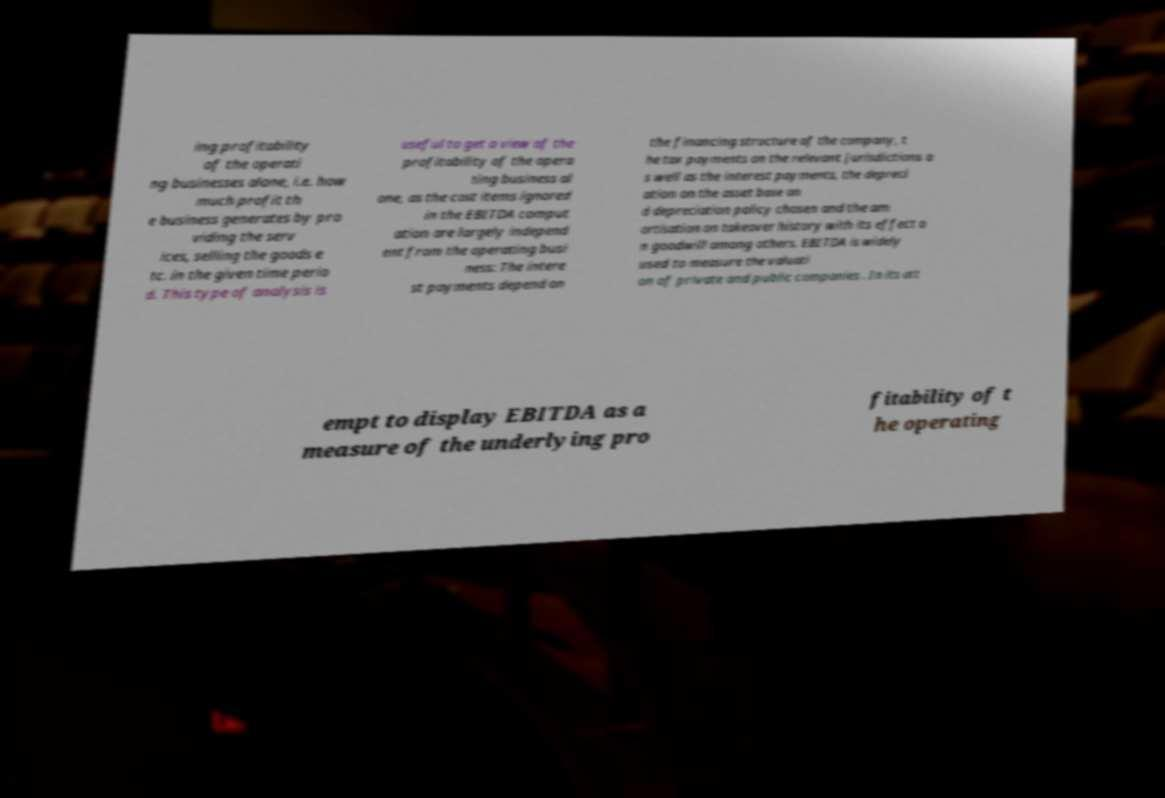Please identify and transcribe the text found in this image. ing profitability of the operati ng businesses alone, i.e. how much profit th e business generates by pro viding the serv ices, selling the goods e tc. in the given time perio d. This type of analysis is useful to get a view of the profitability of the opera ting business al one, as the cost items ignored in the EBITDA comput ation are largely independ ent from the operating busi ness: The intere st payments depend on the financing structure of the company, t he tax payments on the relevant jurisdictions a s well as the interest payments, the depreci ation on the asset base an d depreciation policy chosen and the am ortisation on takeover history with its effect o n goodwill among others. EBITDA is widely used to measure the valuati on of private and public companies . In its att empt to display EBITDA as a measure of the underlying pro fitability of t he operating 